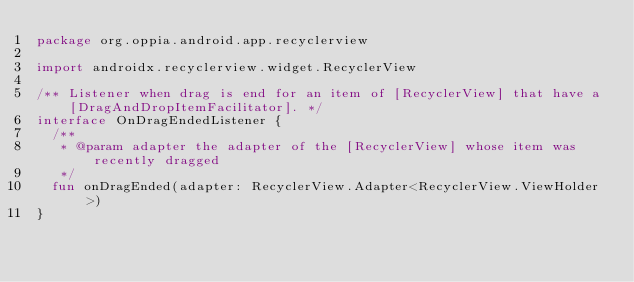<code> <loc_0><loc_0><loc_500><loc_500><_Kotlin_>package org.oppia.android.app.recyclerview

import androidx.recyclerview.widget.RecyclerView

/** Listener when drag is end for an item of [RecyclerView] that have a [DragAndDropItemFacilitator]. */
interface OnDragEndedListener {
  /**
   * @param adapter the adapter of the [RecyclerView] whose item was recently dragged
   */
  fun onDragEnded(adapter: RecyclerView.Adapter<RecyclerView.ViewHolder>)
}
</code> 